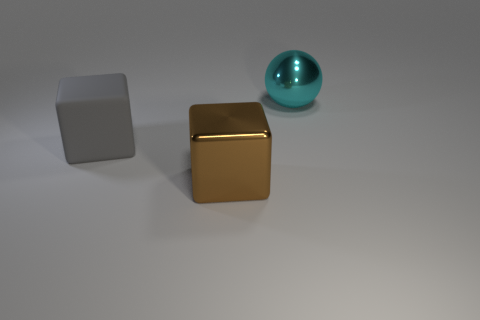What number of gray matte blocks are in front of the object to the right of the metal thing in front of the sphere?
Your answer should be compact. 1. How many other objects are there of the same shape as the large matte thing?
Your response must be concise. 1. How many large cyan spheres are in front of the matte thing?
Your answer should be very brief. 0. Is the number of cyan objects that are on the left side of the large gray matte object less than the number of large matte blocks in front of the big sphere?
Your response must be concise. Yes. The metal thing that is on the left side of the metallic thing behind the big shiny object that is to the left of the large cyan metal thing is what shape?
Offer a terse response. Cube. What is the shape of the large thing that is both behind the large brown metal thing and to the right of the large gray thing?
Your answer should be compact. Sphere. Is there a big gray block that has the same material as the large ball?
Make the answer very short. No. What is the color of the big thing on the right side of the big brown shiny block?
Your answer should be very brief. Cyan. Does the big gray thing have the same shape as the large metallic thing behind the big gray object?
Give a very brief answer. No. What size is the other object that is the same material as the large brown thing?
Make the answer very short. Large. 